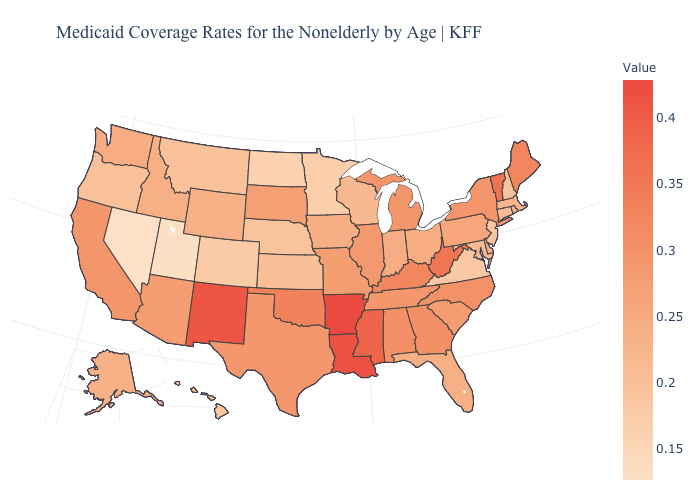Among the states that border North Dakota , which have the highest value?
Give a very brief answer. South Dakota. Is the legend a continuous bar?
Quick response, please. Yes. Does South Dakota have a higher value than Massachusetts?
Short answer required. Yes. Which states hav the highest value in the Northeast?
Quick response, please. Vermont. Does Nevada have the highest value in the West?
Short answer required. No. Which states have the lowest value in the Northeast?
Write a very short answer. New Jersey. Is the legend a continuous bar?
Give a very brief answer. Yes. Does Mississippi have a higher value than Arkansas?
Quick response, please. No. 